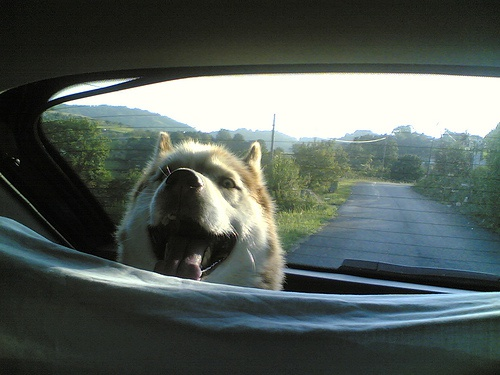Describe the objects in this image and their specific colors. I can see a dog in black, gray, beige, and darkgray tones in this image. 